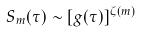Convert formula to latex. <formula><loc_0><loc_0><loc_500><loc_500>S _ { m } ( \tau ) \sim [ g ( \tau ) ] ^ { \zeta ( m ) }</formula> 